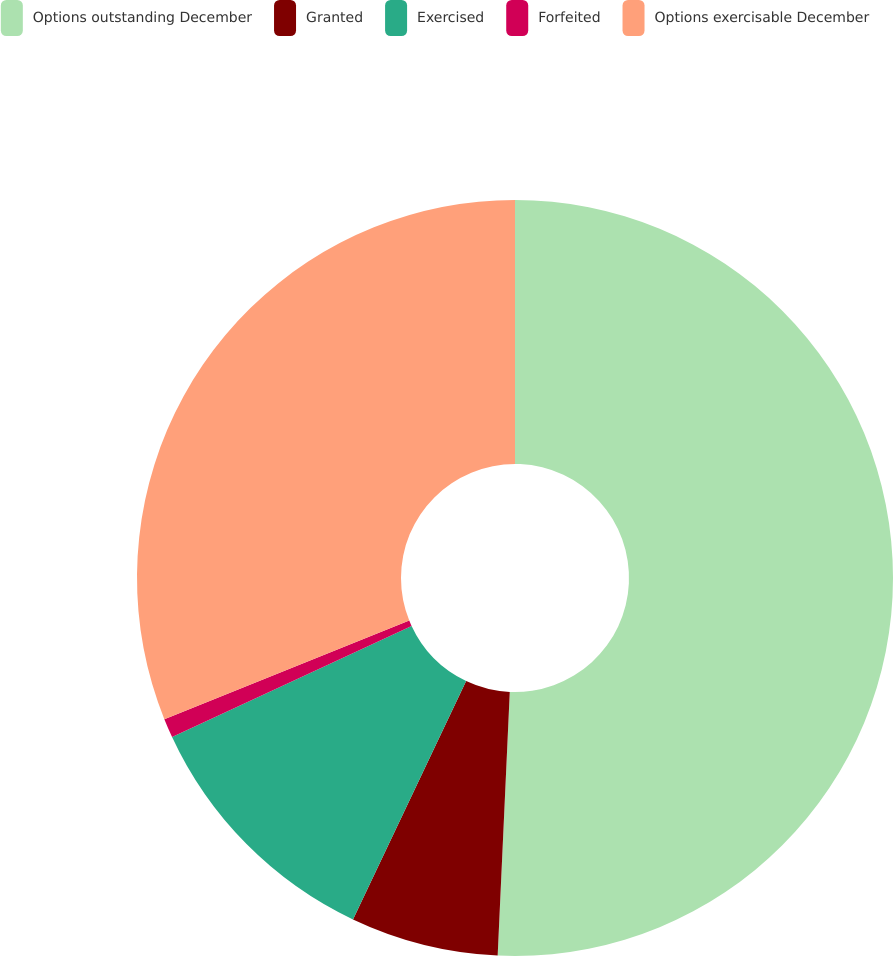Convert chart. <chart><loc_0><loc_0><loc_500><loc_500><pie_chart><fcel>Options outstanding December<fcel>Granted<fcel>Exercised<fcel>Forfeited<fcel>Options exercisable December<nl><fcel>50.73%<fcel>6.32%<fcel>11.04%<fcel>0.82%<fcel>31.09%<nl></chart> 